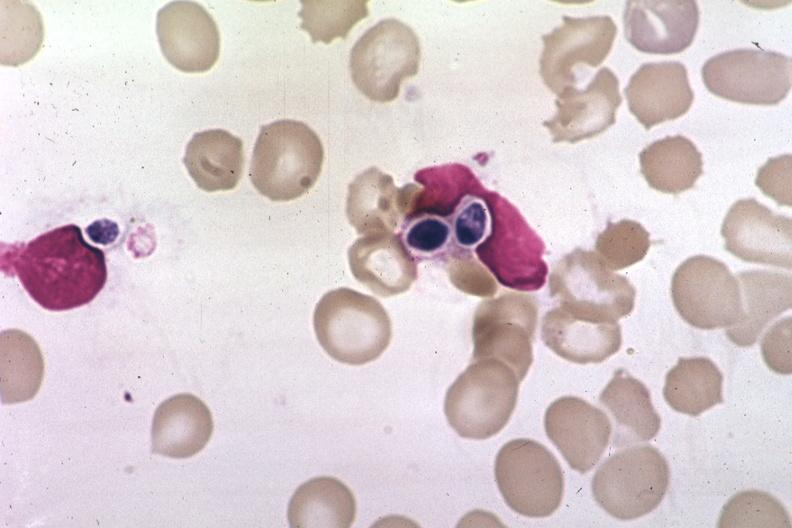what is present?
Answer the question using a single word or phrase. Candida in peripheral blood 